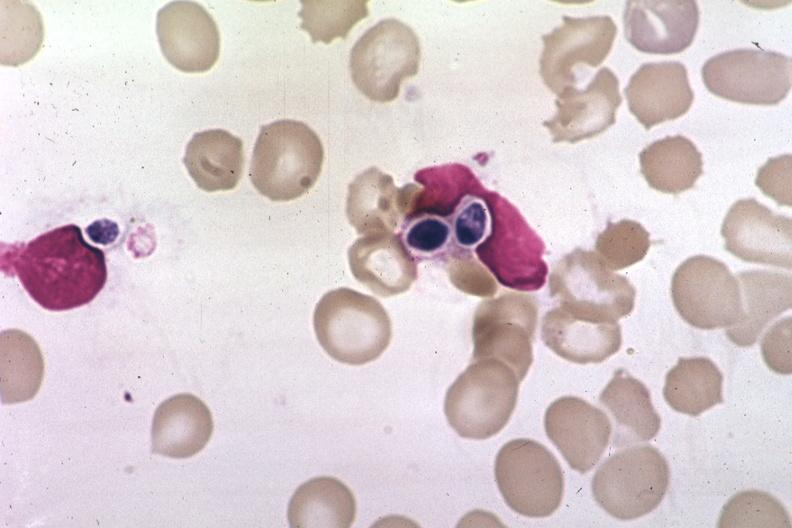what is present?
Answer the question using a single word or phrase. Candida in peripheral blood 